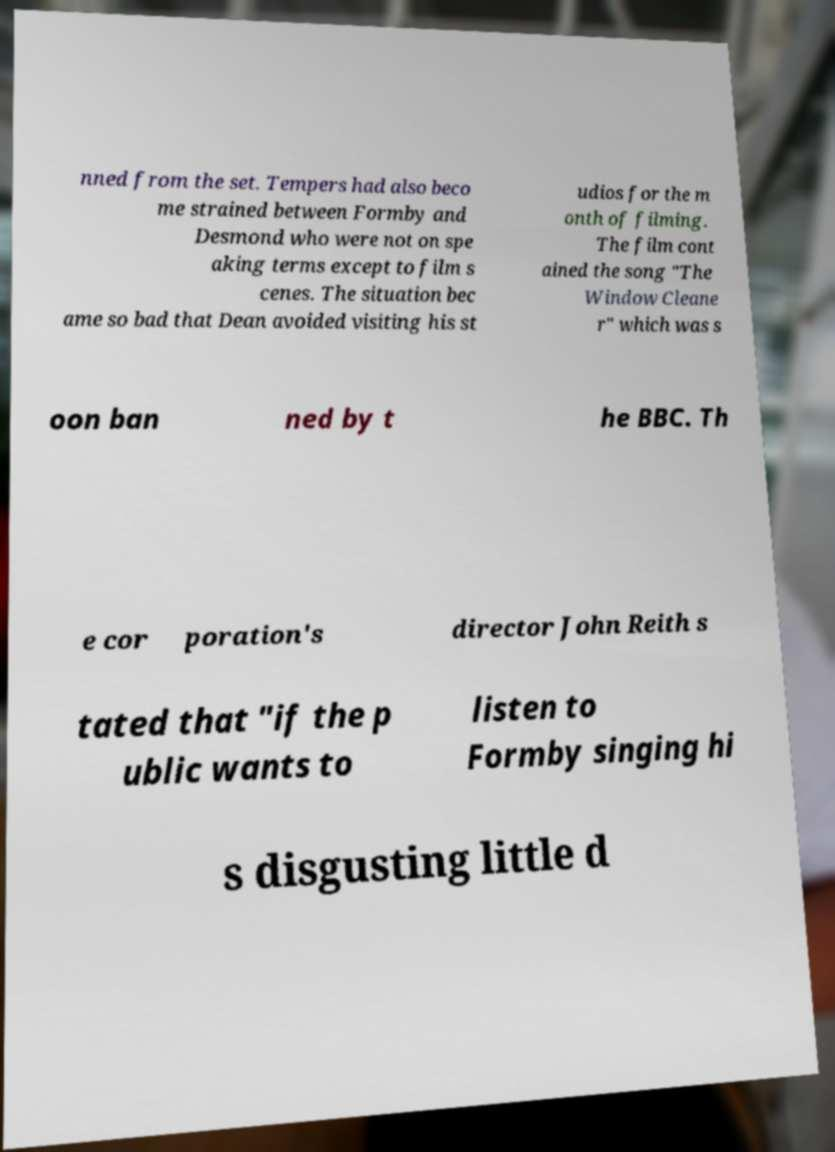Can you read and provide the text displayed in the image?This photo seems to have some interesting text. Can you extract and type it out for me? nned from the set. Tempers had also beco me strained between Formby and Desmond who were not on spe aking terms except to film s cenes. The situation bec ame so bad that Dean avoided visiting his st udios for the m onth of filming. The film cont ained the song "The Window Cleane r" which was s oon ban ned by t he BBC. Th e cor poration's director John Reith s tated that "if the p ublic wants to listen to Formby singing hi s disgusting little d 